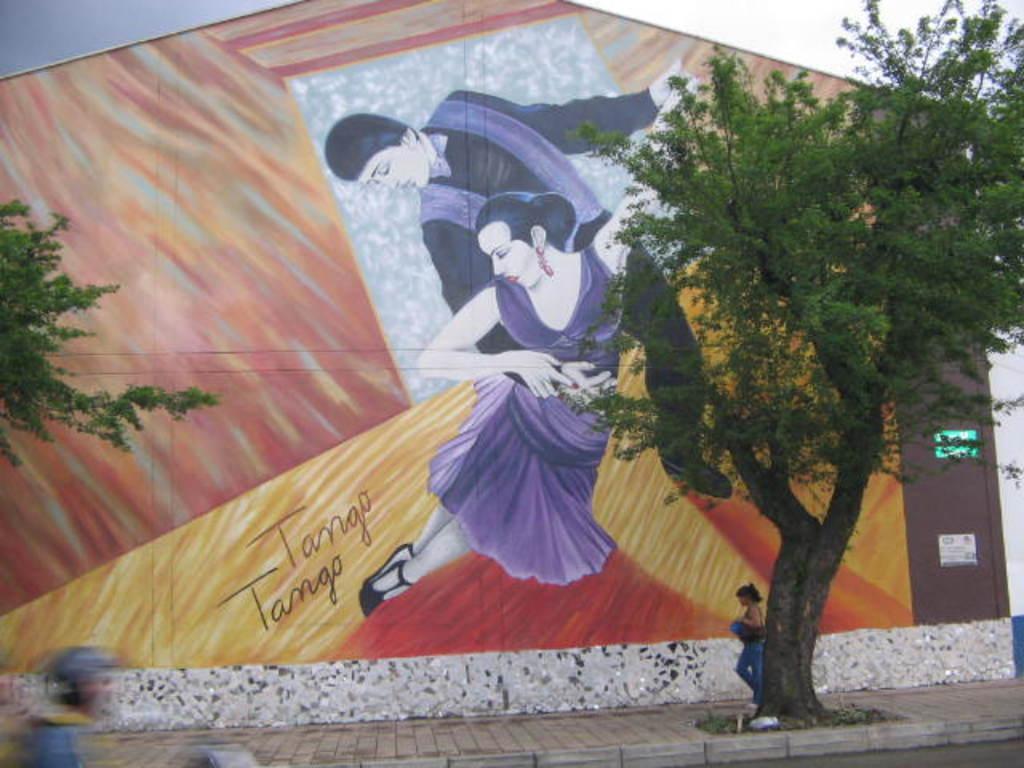How would you summarize this image in a sentence or two? This is the wall painting of the man and woman dancing. These are the trees. I can see a woman walking on the footpath. I think there is a person riding a vehicle. This looks like a road. 